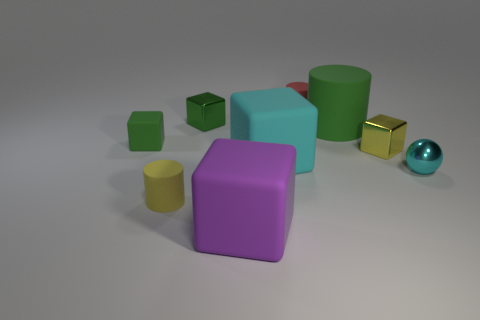What can you tell me about the lighting in this scene? The lighting in the scene appears diffused, softening shadows and allowing the colors of the objects to be distinctly visible without harsh contrasts. 